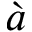Convert formula to latex. <formula><loc_0><loc_0><loc_500><loc_500>\grave { a }</formula> 